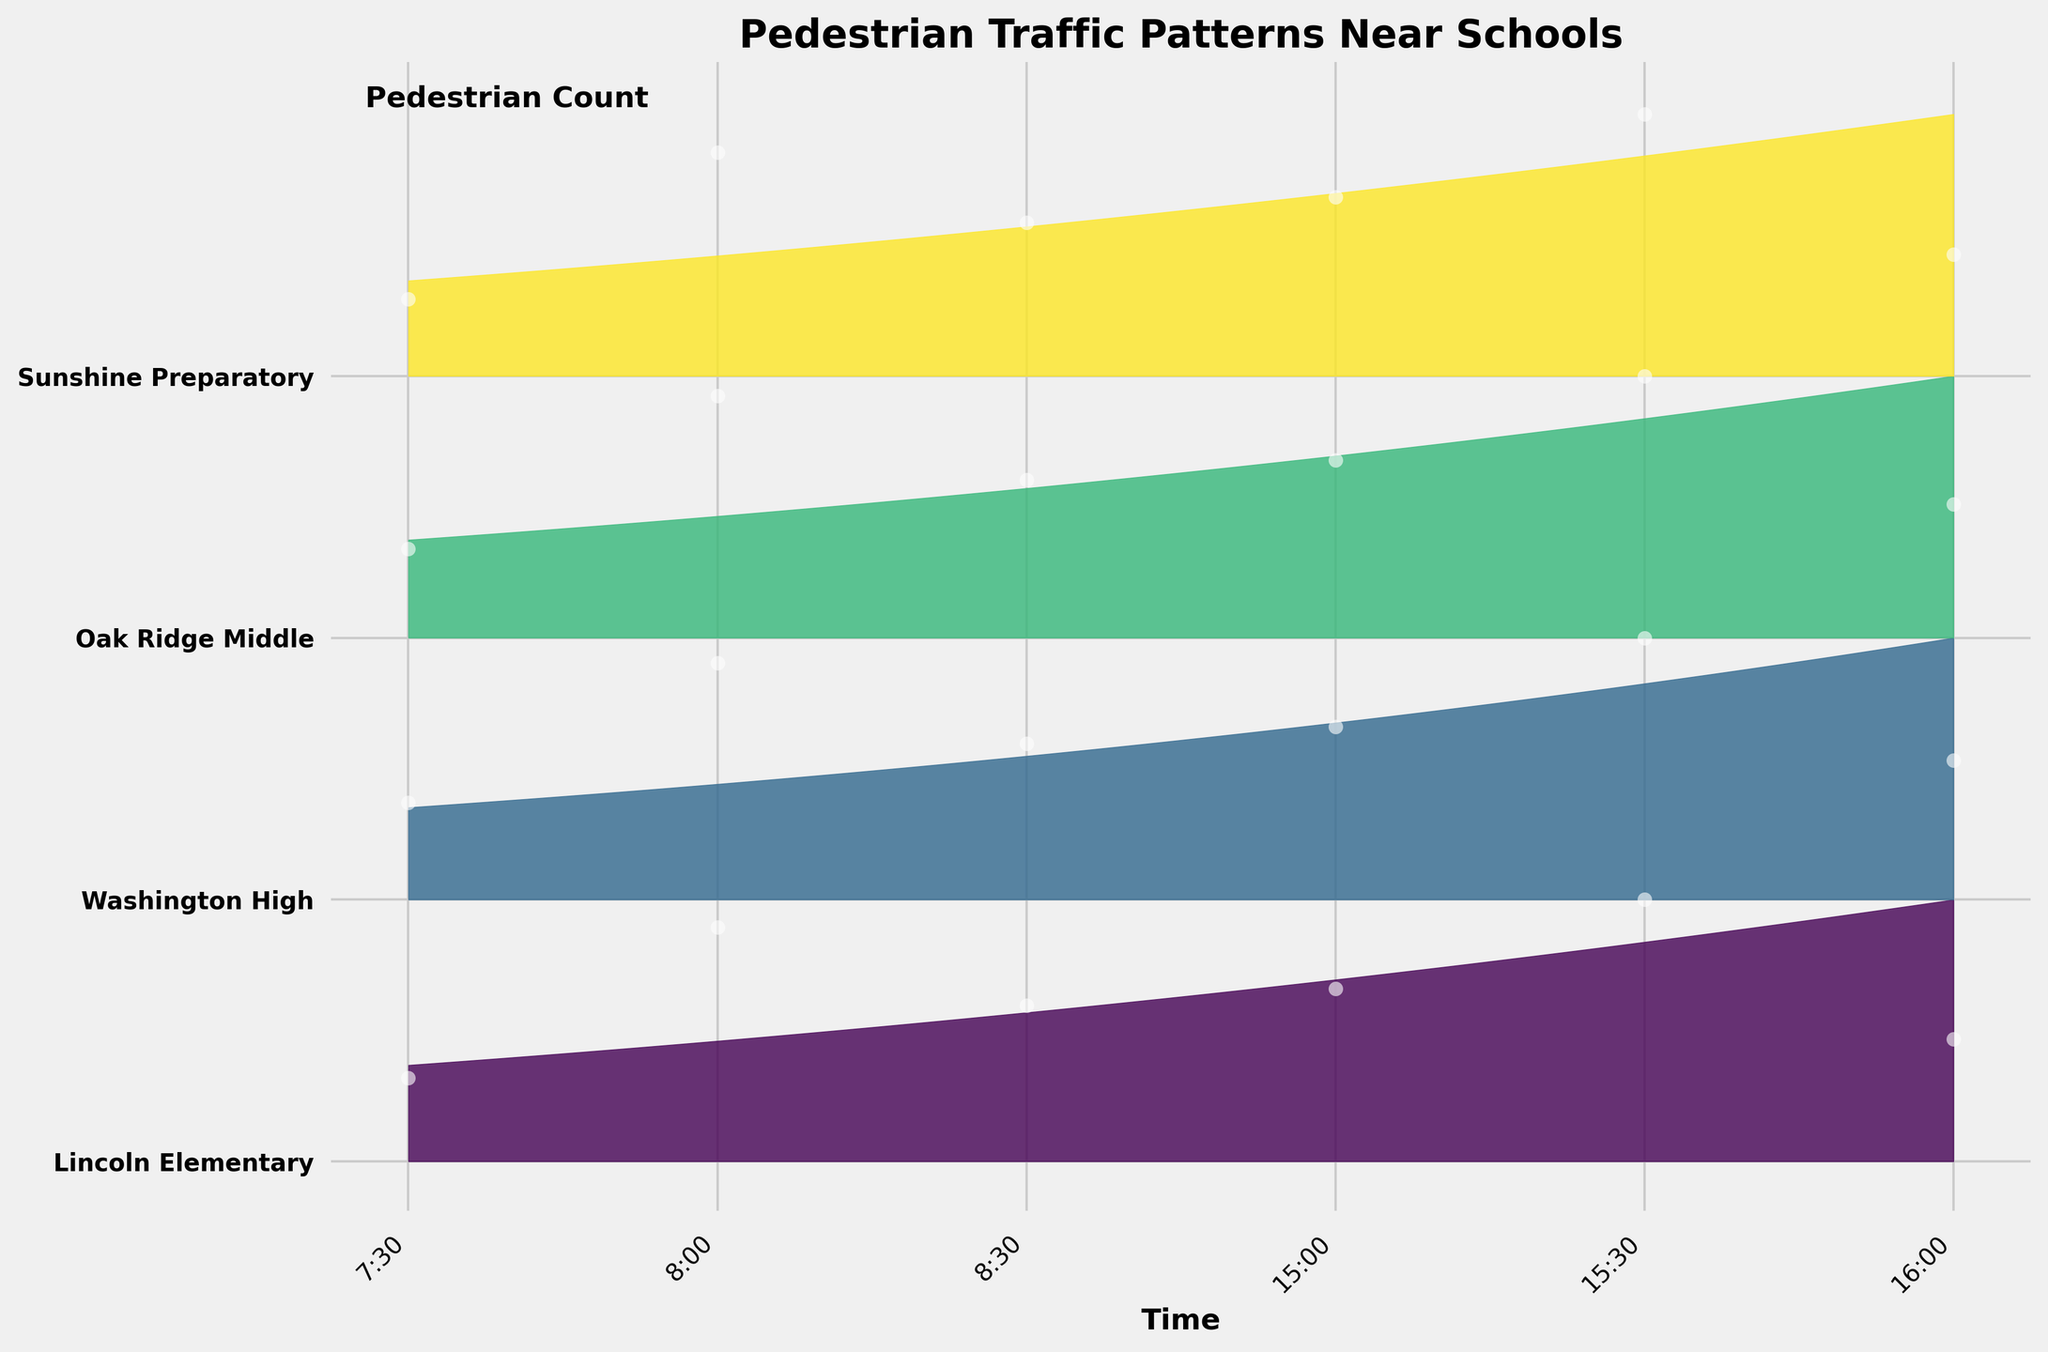Which school has the highest pedestrian traffic during the morning peak at 8:00? Looking at 8:00 on the x-axis and comparing the heights of the data points for all schools, Washington High has the highest peak.
Answer: Washington High What is the average pedestrian count for Oak Ridge Middle in the morning peak times (7:30, 8:00, 8:30)? Adding the pedestrian counts for Oak Ridge Middle at 7:30 (18), 8:00 (49), and 8:30 (32) and then dividing by 3 gives the average: (18 + 49 + 32) / 3 = 33.
Answer: 33 Which school has the largest increase in pedestrian traffic from 7:30 to 8:00? By calculating the difference between 8:00 and 7:30 counts for each school, Washington High has the largest increase (56 - 23 = 33).
Answer: Washington High At which time intervals do all schools see an increase in pedestrian count compared to the previous time interval? Comparing counts from 7:30 to 8:00 and from 15:00 to 15:30, both show increases across all schools.
Answer: 7:30 to 8:00, 15:00 to 15:30 Which time slot shows the least variability in pedestrian counts across all schools? Comparing the spread of the data points on the y-axis for each time slot, 16:00 shows the least variability.
Answer: 16:00 What is the total pedestrian count for Sunshine Preparatory throughout the day? Adding the pedestrian counts for Sunshine Preparatory at all times: 12 + 35 + 24 + 28 + 41 + 19 = 159.
Answer: 159 Which school's pedestrian traffic pattern shows the most symmetry around the peak time of 8:00? Observing the shapes of the ridgelines, Lincoln Elementary has a fairly symmetrical pattern around 8:00.
Answer: Lincoln Elementary What is the difference in pedestrian count between the highest peak (Washington High at 8:00) and the lowest peak (Sunshine Preparatory at 7:30)? Subtracting the lowest count from the highest count: 56 - 12 = 44.
Answer: 44 How do the pedestrian traffic patterns between Lincoln Elementary and Oak Ridge Middle compare at 15:30? Both schools show high peaks; Lincoln Elementary has 47, while Oak Ridge Middle has 53, with Oak Ridge Middle having a slightly higher count.
Answer: Oak Ridge Middle has higher traffic Which school's pedestrian traffic decreases the most from 8:30 to 16:00? Calculating the difference in counts between 8:30 and 16:00 for each school, Lincoln Elementary shows the largest decrease (28 - 22 = 6).
Answer: Lincoln Elementary 